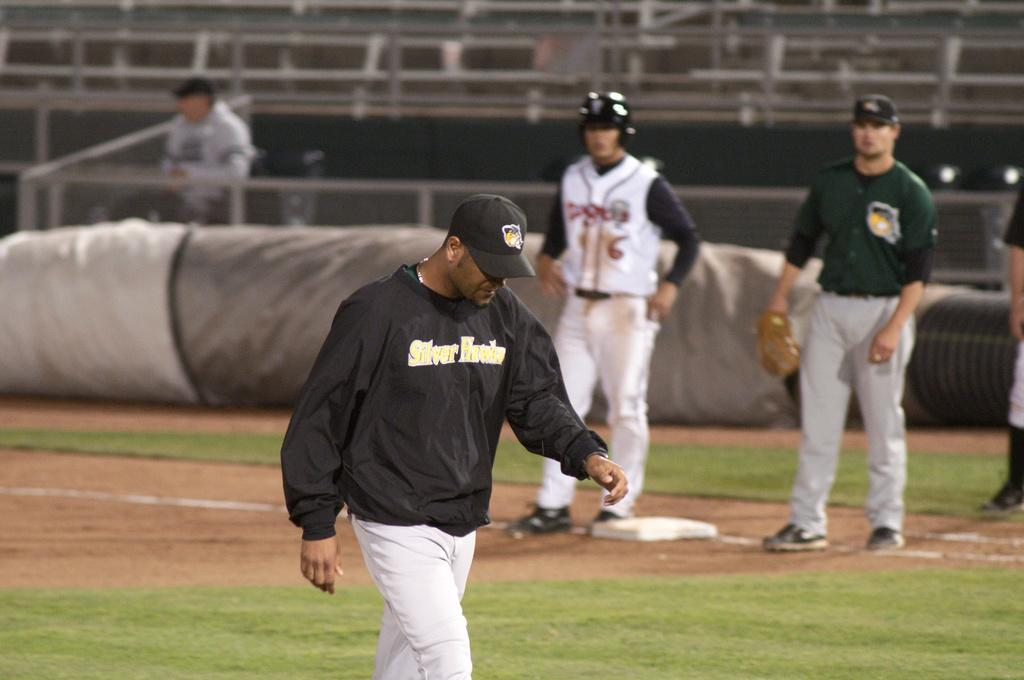<image>
Share a concise interpretation of the image provided. Baseball player wearing a sweater that says Silver Falcons on the front. 